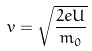Convert formula to latex. <formula><loc_0><loc_0><loc_500><loc_500>v = \sqrt { \frac { 2 e U } { m _ { 0 } } }</formula> 